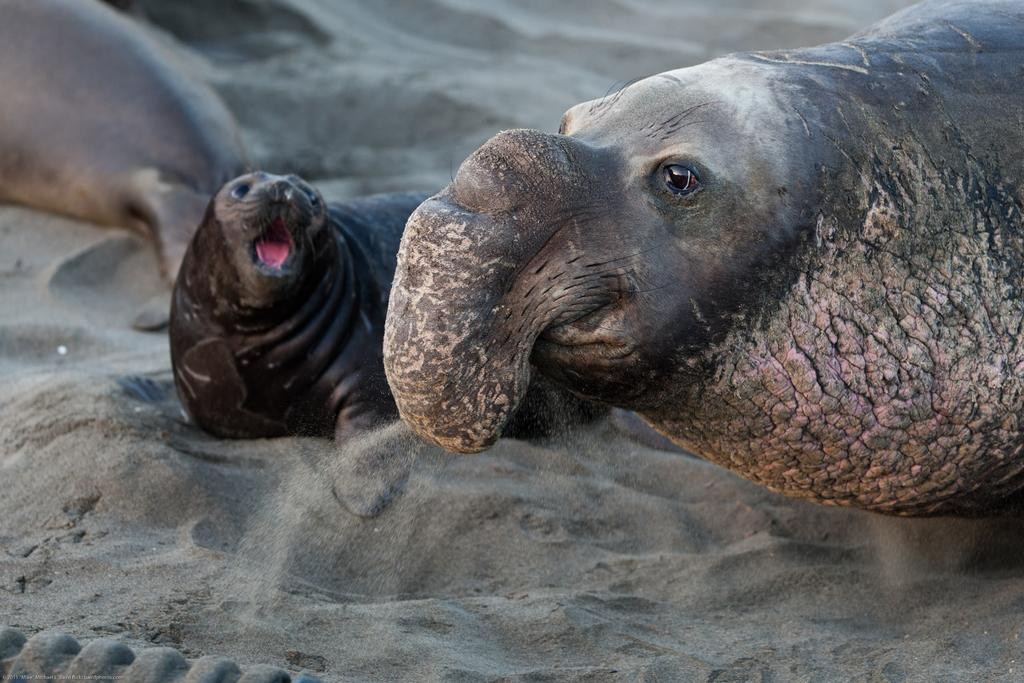What type of animals are in the image? There are elephant seals in the image. Where are the elephant seals located? The elephant seals are present on the ground. What type of terrain is visible in the image? There is sand visible in the image. What degree do the elephant seals have in the image? Elephant seals do not have degrees, as they are animals and not humans. 